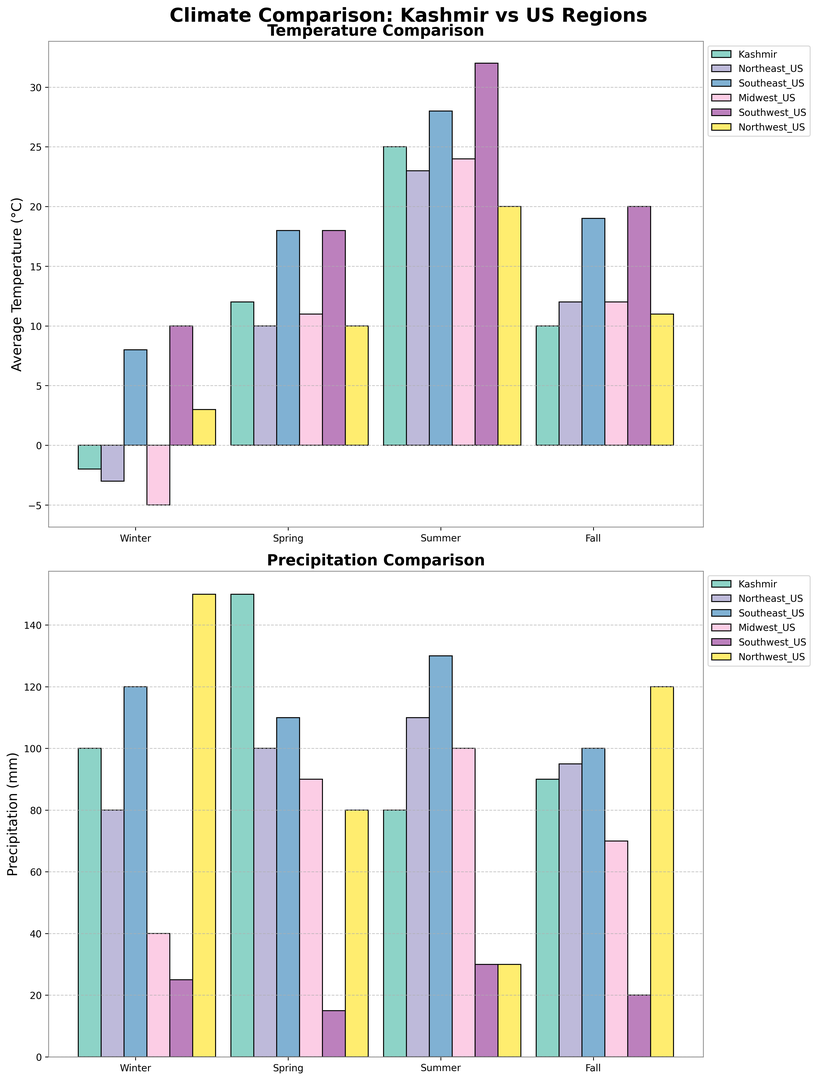Which region experiences the lowest average temperature in winter? To find the region with the lowest average temperature in winter, look at the bars representing winter temperatures and identify the shortest bar. The shortest bar corresponds to the Midwest_US region with -5°C.
Answer: Midwest_US Which season has the highest average precipitation for Kashmir? To identify the season with the highest average precipitation for Kashmir, look at the heights of the precipitation bars for Kashmir across all seasons and find the tallest bar. The tallest bar is in Spring with 150 mm.
Answer: Spring How much warmer is the summer average temperature in Southeast_US compared to Kashmir? Find the summer temperature bars for Southeast_US and Kashmir. Subtract Kashmir's average summer temperature (25°C) from Southeast_US's average summer temperature (28°C) to get the difference. 28 - 25 = 3°C warmer.
Answer: 3°C Which region has the least precipitation in summer? Observe the summer precipitation bars across all regions and identify the shortest bar. The shortest bar corresponds to Southwest_US with 30 mm of summer precipitation.
Answer: Southwest_US Compare the average winter temperatures between Northeast_US and Northwest_US. Which one is higher and by how much? Check the winter temperature bars for Northeast_US and Northwest_US. Northeast_US has -3°C and Northwest_US has 3°C. The difference is 3 - (-3) = 6°C higher in Northwest_US.
Answer: Northwest_US, by 6°C Which region has the most consistent average temperature across all seasons? For consistent temperature, look for minimal variation in bar heights across all seasons for each region. The smallest variation in heights is observed for Southwest_US.
Answer: Southwest_US How does the average fall precipitation in Northwest_US compare to Kashmir? Compare the fall precipitation bars for Northwest_US and Kashmir. Northwest_US has 120 mm and Kashmir has 90 mm. The bars show that Northwest_US has 30 mm more precipitation than Kashmir.
Answer: Northwest_US has 30 mm more Which region experienced the highest average temperature in summer and what was the temperature? Find the highest summer temperature bar among all regions. The tallest bar corresponds to Southwest_US with 32°C.
Answer: Southwest_US, 32°C What is the difference in average spring temperatures between Midwest_US and Northeast_US? Check the spring temperature bars for Midwest_US and Northeast_US. Midwest_US has 11°C and Northeast_US has 10°C, so the difference is 11 - 10 = 1°C.
Answer: 1°C Which season in Kashmir has the lowest average temperature and which one in Southwest_US has the highest average temperature? For Kashmir, look at the temperature bars and find the shortest one for the lowest temperature, which is winter with -2°C. For Southwest_US, find the tallest bar indicating the highest temperature, which is summer with 32°C.
Answer: Winter in Kashmir, Summer in Southwest_US 